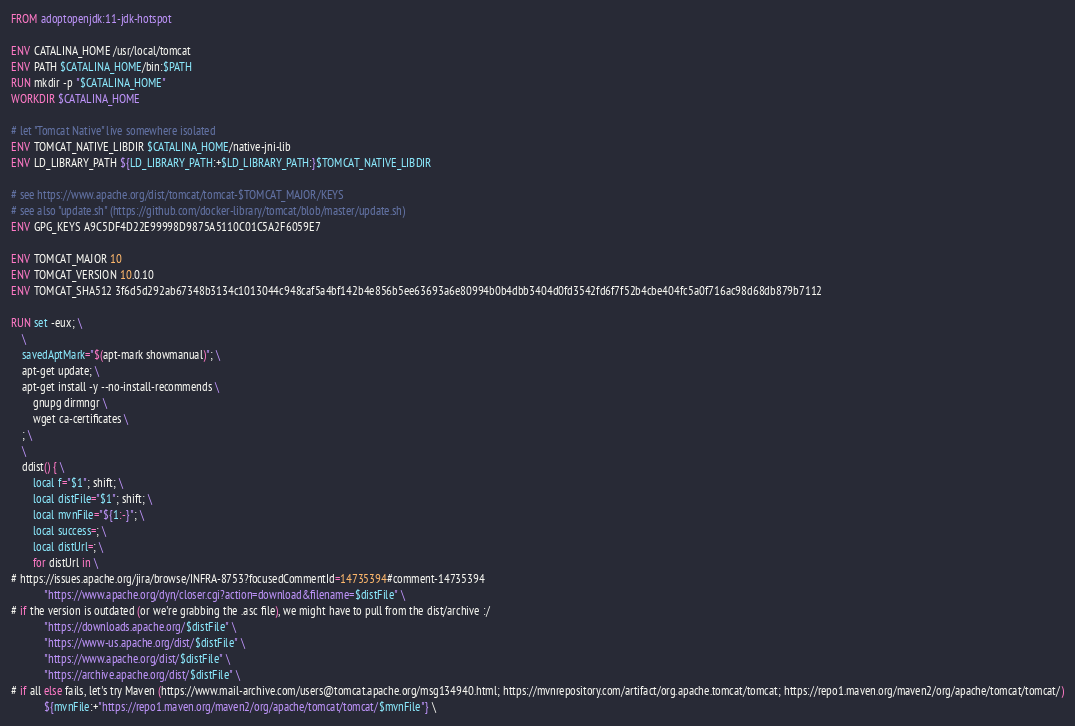<code> <loc_0><loc_0><loc_500><loc_500><_Dockerfile_>FROM adoptopenjdk:11-jdk-hotspot

ENV CATALINA_HOME /usr/local/tomcat
ENV PATH $CATALINA_HOME/bin:$PATH
RUN mkdir -p "$CATALINA_HOME"
WORKDIR $CATALINA_HOME

# let "Tomcat Native" live somewhere isolated
ENV TOMCAT_NATIVE_LIBDIR $CATALINA_HOME/native-jni-lib
ENV LD_LIBRARY_PATH ${LD_LIBRARY_PATH:+$LD_LIBRARY_PATH:}$TOMCAT_NATIVE_LIBDIR

# see https://www.apache.org/dist/tomcat/tomcat-$TOMCAT_MAJOR/KEYS
# see also "update.sh" (https://github.com/docker-library/tomcat/blob/master/update.sh)
ENV GPG_KEYS A9C5DF4D22E99998D9875A5110C01C5A2F6059E7

ENV TOMCAT_MAJOR 10
ENV TOMCAT_VERSION 10.0.10
ENV TOMCAT_SHA512 3f6d5d292ab67348b3134c1013044c948caf5a4bf142b4e856b5ee63693a6e80994b0b4dbb3404d0fd3542fd6f7f52b4cbe404fc5a0f716ac98d68db879b7112

RUN set -eux; \
	\
	savedAptMark="$(apt-mark showmanual)"; \
	apt-get update; \
	apt-get install -y --no-install-recommends \
		gnupg dirmngr \
		wget ca-certificates \
	; \
	\
	ddist() { \
		local f="$1"; shift; \
		local distFile="$1"; shift; \
		local mvnFile="${1:-}"; \
		local success=; \
		local distUrl=; \
		for distUrl in \
# https://issues.apache.org/jira/browse/INFRA-8753?focusedCommentId=14735394#comment-14735394
			"https://www.apache.org/dyn/closer.cgi?action=download&filename=$distFile" \
# if the version is outdated (or we're grabbing the .asc file), we might have to pull from the dist/archive :/
			"https://downloads.apache.org/$distFile" \
			"https://www-us.apache.org/dist/$distFile" \
			"https://www.apache.org/dist/$distFile" \
			"https://archive.apache.org/dist/$distFile" \
# if all else fails, let's try Maven (https://www.mail-archive.com/users@tomcat.apache.org/msg134940.html; https://mvnrepository.com/artifact/org.apache.tomcat/tomcat; https://repo1.maven.org/maven2/org/apache/tomcat/tomcat/)
			${mvnFile:+"https://repo1.maven.org/maven2/org/apache/tomcat/tomcat/$mvnFile"} \</code> 